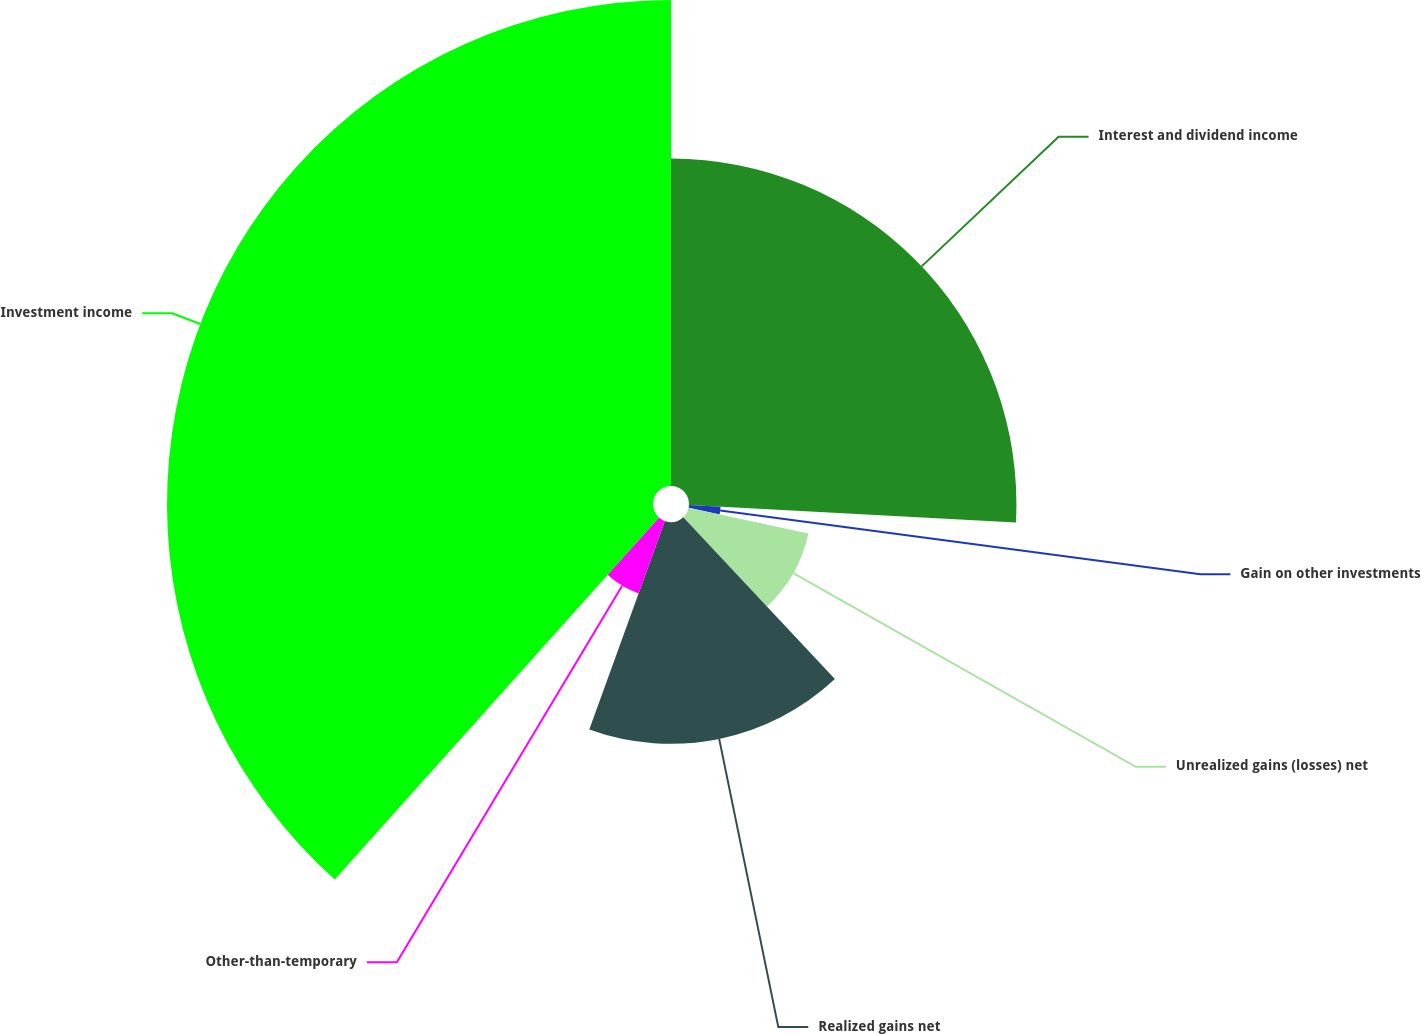Convert chart. <chart><loc_0><loc_0><loc_500><loc_500><pie_chart><fcel>Interest and dividend income<fcel>Gain on other investments<fcel>Unrealized gains (losses) net<fcel>Realized gains net<fcel>Other-than-temporary<fcel>Investment income<nl><fcel>25.85%<fcel>2.5%<fcel>9.67%<fcel>17.51%<fcel>6.09%<fcel>38.37%<nl></chart> 